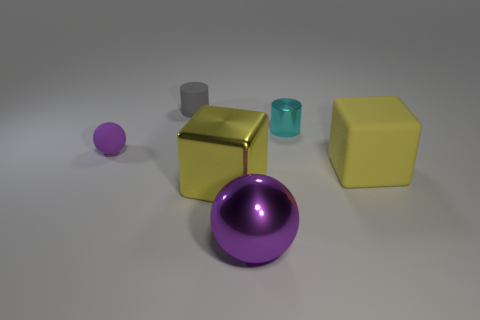How many other things are there of the same material as the small gray cylinder?
Ensure brevity in your answer.  2. The matte thing that is both in front of the small cyan shiny cylinder and on the left side of the big rubber cube is what color?
Make the answer very short. Purple. Is the material of the small object that is on the right side of the big metal ball the same as the ball in front of the small matte ball?
Offer a terse response. Yes. There is a yellow cube that is on the right side of the cyan object; is its size the same as the yellow metallic object?
Provide a short and direct response. Yes. Does the small sphere have the same color as the rubber thing to the right of the gray thing?
Your response must be concise. No. What is the shape of the thing that is the same color as the tiny ball?
Provide a short and direct response. Sphere. The tiny shiny thing has what shape?
Make the answer very short. Cylinder. Does the large metallic block have the same color as the rubber block?
Offer a terse response. Yes. How many things are either large blocks that are to the left of the tiny metal cylinder or gray matte cylinders?
Offer a very short reply. 2. The purple ball that is made of the same material as the gray cylinder is what size?
Your answer should be very brief. Small. 